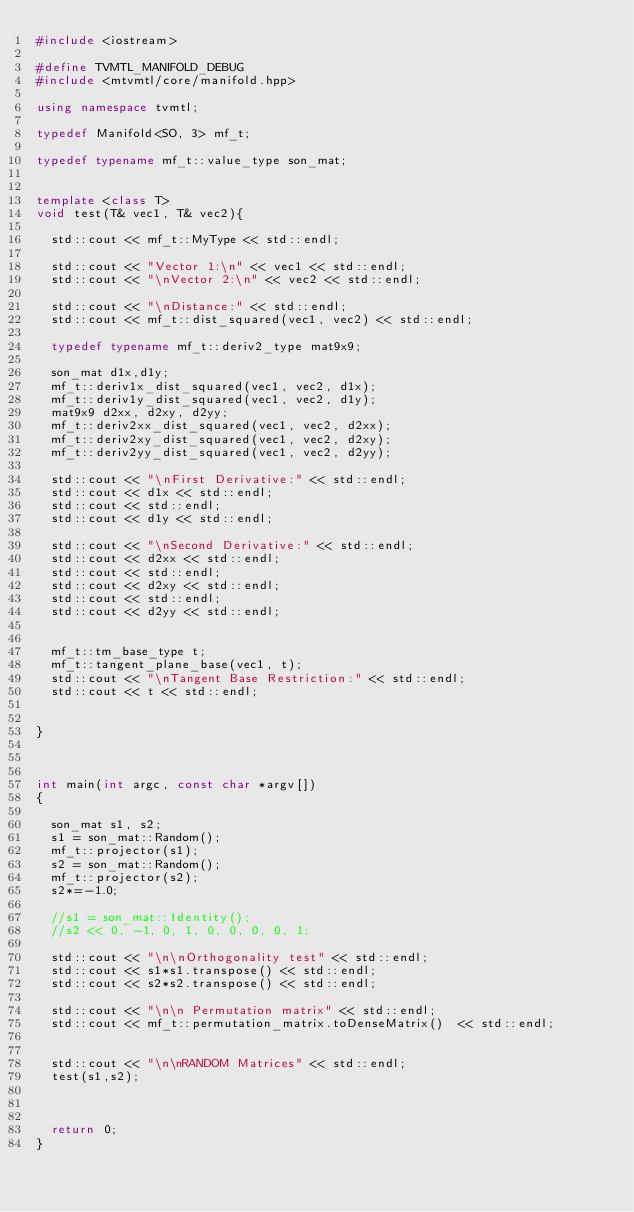<code> <loc_0><loc_0><loc_500><loc_500><_C++_>#include <iostream>

#define TVMTL_MANIFOLD_DEBUG
#include <mtvmtl/core/manifold.hpp>

using namespace tvmtl;

typedef Manifold<SO, 3> mf_t;

typedef typename mf_t::value_type son_mat;


template <class T>
void test(T& vec1, T& vec2){

	std::cout << mf_t::MyType << std::endl;
	
	std::cout << "Vector 1:\n" << vec1 << std::endl;
	std::cout << "\nVector 2:\n" << vec2 << std::endl;

	std::cout << "\nDistance:" << std::endl;
	std::cout << mf_t::dist_squared(vec1, vec2) << std::endl;

	typedef typename mf_t::deriv2_type mat9x9;

	son_mat d1x,d1y;
	mf_t::deriv1x_dist_squared(vec1, vec2, d1x);
	mf_t::deriv1y_dist_squared(vec1, vec2, d1y);
	mat9x9 d2xx, d2xy, d2yy; 
	mf_t::deriv2xx_dist_squared(vec1, vec2, d2xx);
	mf_t::deriv2xy_dist_squared(vec1, vec2, d2xy);
	mf_t::deriv2yy_dist_squared(vec1, vec2, d2yy);
	
	std::cout << "\nFirst Derivative:" << std::endl;
	std::cout << d1x << std::endl;
	std::cout << std::endl;
	std::cout << d1y << std::endl;

	std::cout << "\nSecond Derivative:" << std::endl;
	std::cout << d2xx << std::endl;
	std::cout << std::endl;
	std::cout << d2xy << std::endl;
	std::cout << std::endl;
	std::cout << d2yy << std::endl;


	mf_t::tm_base_type t;
	mf_t::tangent_plane_base(vec1, t);
	std::cout << "\nTangent Base Restriction:" << std::endl;
	std::cout << t << std::endl;


}



int main(int argc, const char *argv[])
{
 
	son_mat s1, s2;
	s1 = son_mat::Random();
	mf_t::projector(s1);
	s2 = son_mat::Random();
	mf_t::projector(s2);
	s2*=-1.0;
	
	//s1 = son_mat::Identity();
	//s2 << 0, -1, 0, 1, 0, 0, 0, 0, 1;

	std::cout << "\n\nOrthogonality test" << std::endl;
	std::cout << s1*s1.transpose() << std::endl;
	std::cout << s2*s2.transpose() << std::endl;

	std::cout << "\n\n Permutation matrix" << std::endl;
	std::cout << mf_t::permutation_matrix.toDenseMatrix()  << std::endl;


	std::cout << "\n\nRANDOM Matrices" << std::endl;
	test(s1,s2);



	return 0;
}
</code> 